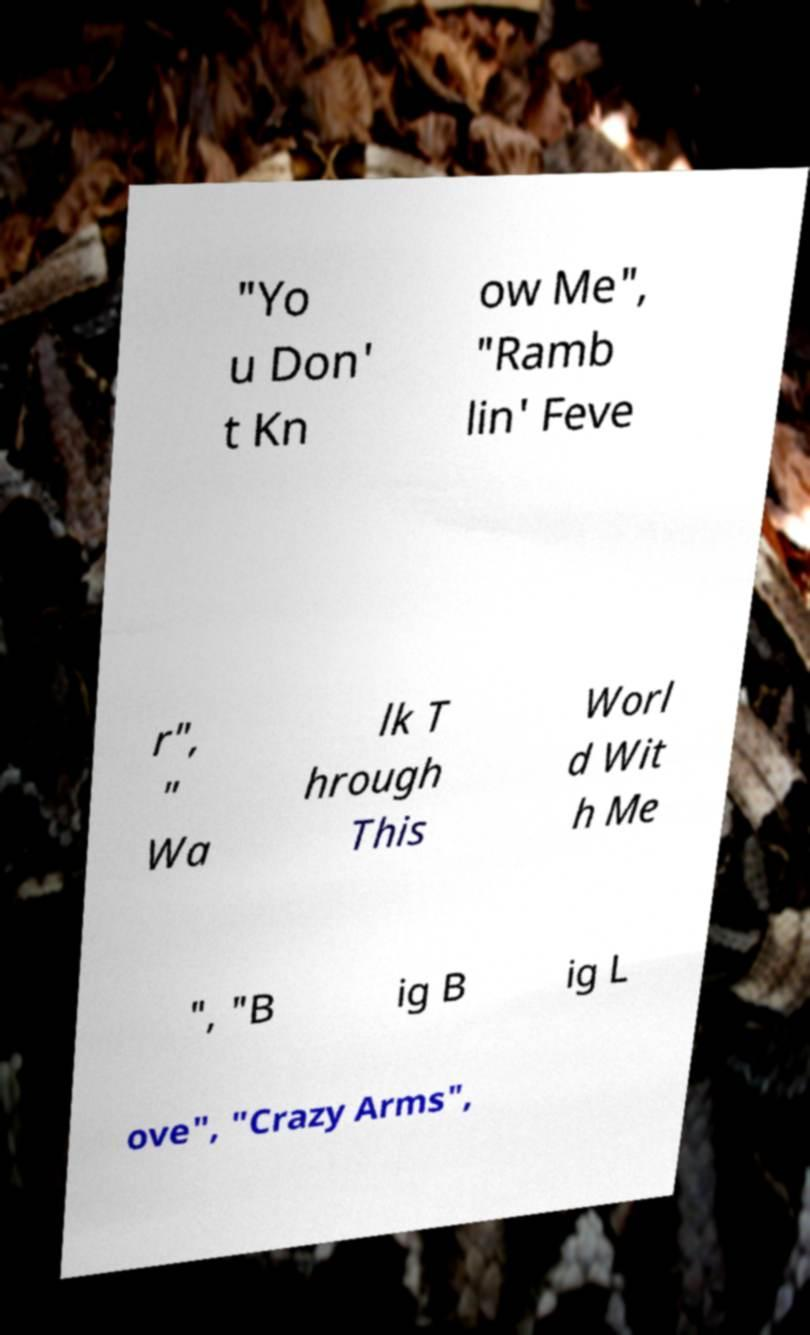There's text embedded in this image that I need extracted. Can you transcribe it verbatim? "Yo u Don' t Kn ow Me", "Ramb lin' Feve r", " Wa lk T hrough This Worl d Wit h Me ", "B ig B ig L ove", "Crazy Arms", 